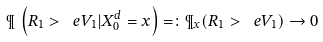<formula> <loc_0><loc_0><loc_500><loc_500>\P \, \left ( R _ { 1 } > \ e V _ { 1 } | X ^ { d } _ { 0 } = x \right ) = \colon \P _ { x } ( R _ { 1 } > \ e V _ { 1 } ) \to 0</formula> 